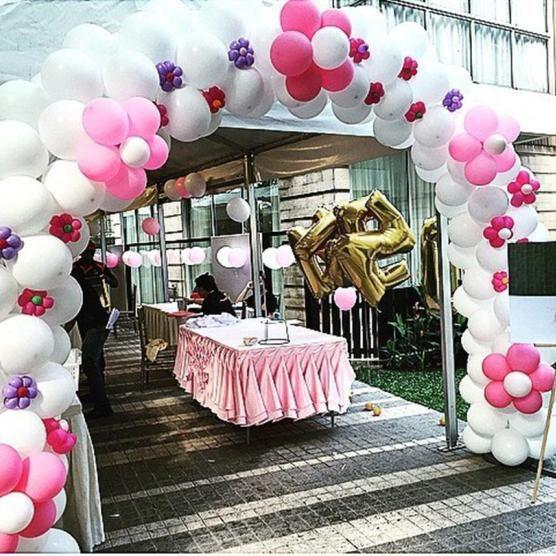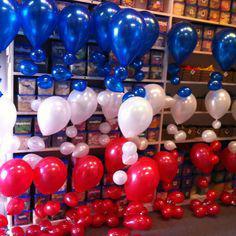The first image is the image on the left, the second image is the image on the right. Evaluate the accuracy of this statement regarding the images: "An image shows a balloon arch that forms a semi-circle and includes white and reddish balloons.". Is it true? Answer yes or no. Yes. The first image is the image on the left, the second image is the image on the right. Assess this claim about the two images: "In at least one image there is a balloon arch that is the same thickness all the way through with at least three rows of balloons..". Correct or not? Answer yes or no. Yes. 